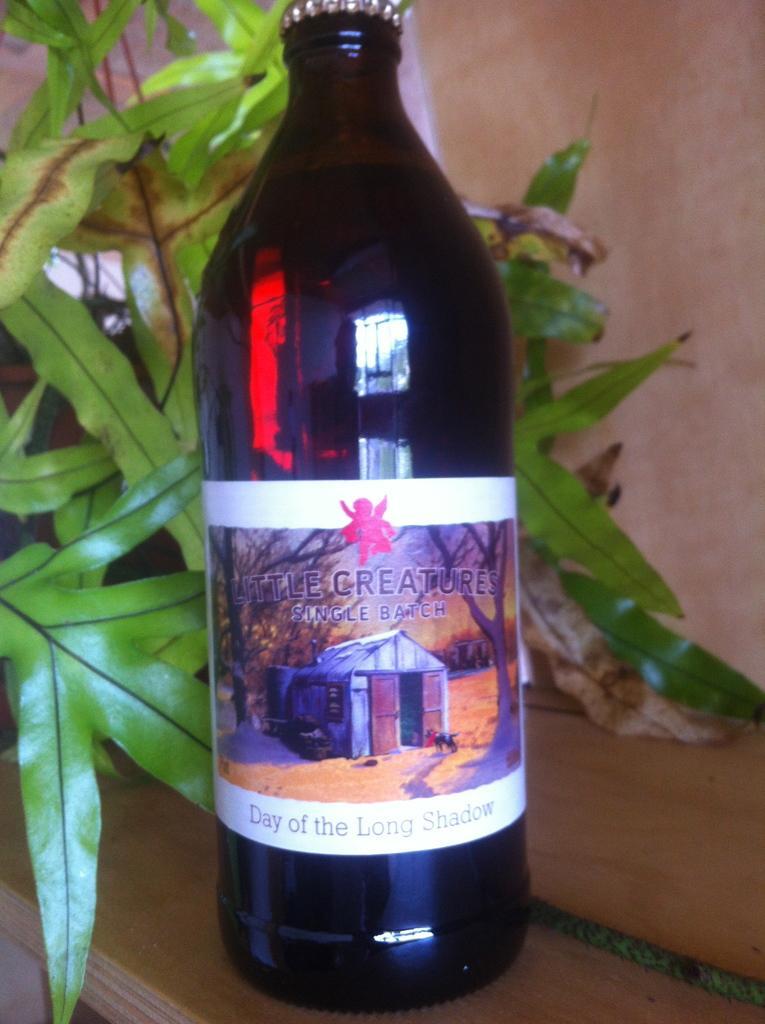Can you describe this image briefly? As we can see in the image there is a pink color wall, plant and a black color bottle. On bottle it was written as "little creatures". 